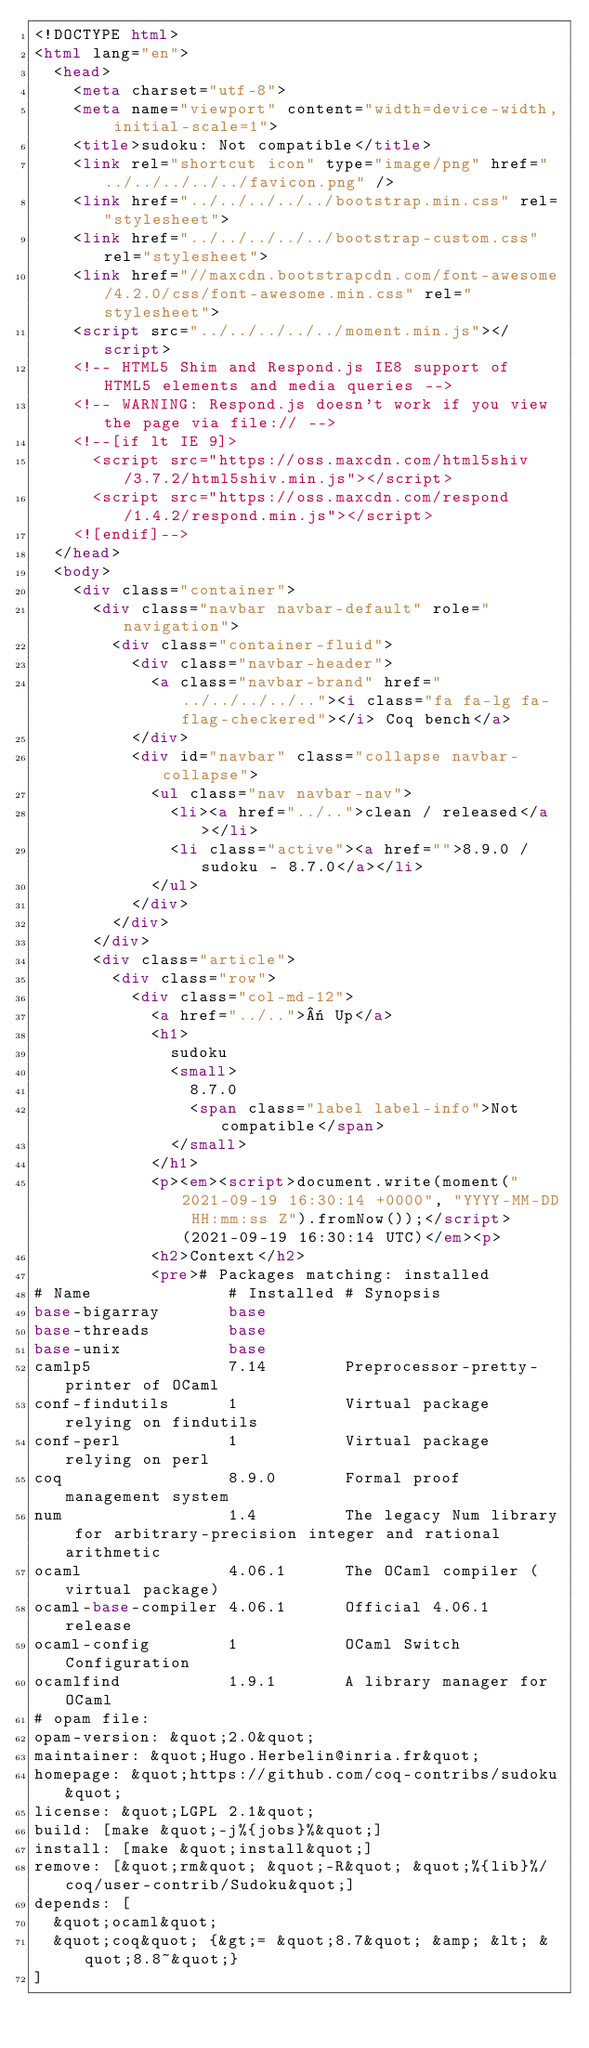Convert code to text. <code><loc_0><loc_0><loc_500><loc_500><_HTML_><!DOCTYPE html>
<html lang="en">
  <head>
    <meta charset="utf-8">
    <meta name="viewport" content="width=device-width, initial-scale=1">
    <title>sudoku: Not compatible</title>
    <link rel="shortcut icon" type="image/png" href="../../../../../favicon.png" />
    <link href="../../../../../bootstrap.min.css" rel="stylesheet">
    <link href="../../../../../bootstrap-custom.css" rel="stylesheet">
    <link href="//maxcdn.bootstrapcdn.com/font-awesome/4.2.0/css/font-awesome.min.css" rel="stylesheet">
    <script src="../../../../../moment.min.js"></script>
    <!-- HTML5 Shim and Respond.js IE8 support of HTML5 elements and media queries -->
    <!-- WARNING: Respond.js doesn't work if you view the page via file:// -->
    <!--[if lt IE 9]>
      <script src="https://oss.maxcdn.com/html5shiv/3.7.2/html5shiv.min.js"></script>
      <script src="https://oss.maxcdn.com/respond/1.4.2/respond.min.js"></script>
    <![endif]-->
  </head>
  <body>
    <div class="container">
      <div class="navbar navbar-default" role="navigation">
        <div class="container-fluid">
          <div class="navbar-header">
            <a class="navbar-brand" href="../../../../.."><i class="fa fa-lg fa-flag-checkered"></i> Coq bench</a>
          </div>
          <div id="navbar" class="collapse navbar-collapse">
            <ul class="nav navbar-nav">
              <li><a href="../..">clean / released</a></li>
              <li class="active"><a href="">8.9.0 / sudoku - 8.7.0</a></li>
            </ul>
          </div>
        </div>
      </div>
      <div class="article">
        <div class="row">
          <div class="col-md-12">
            <a href="../..">« Up</a>
            <h1>
              sudoku
              <small>
                8.7.0
                <span class="label label-info">Not compatible</span>
              </small>
            </h1>
            <p><em><script>document.write(moment("2021-09-19 16:30:14 +0000", "YYYY-MM-DD HH:mm:ss Z").fromNow());</script> (2021-09-19 16:30:14 UTC)</em><p>
            <h2>Context</h2>
            <pre># Packages matching: installed
# Name              # Installed # Synopsis
base-bigarray       base
base-threads        base
base-unix           base
camlp5              7.14        Preprocessor-pretty-printer of OCaml
conf-findutils      1           Virtual package relying on findutils
conf-perl           1           Virtual package relying on perl
coq                 8.9.0       Formal proof management system
num                 1.4         The legacy Num library for arbitrary-precision integer and rational arithmetic
ocaml               4.06.1      The OCaml compiler (virtual package)
ocaml-base-compiler 4.06.1      Official 4.06.1 release
ocaml-config        1           OCaml Switch Configuration
ocamlfind           1.9.1       A library manager for OCaml
# opam file:
opam-version: &quot;2.0&quot;
maintainer: &quot;Hugo.Herbelin@inria.fr&quot;
homepage: &quot;https://github.com/coq-contribs/sudoku&quot;
license: &quot;LGPL 2.1&quot;
build: [make &quot;-j%{jobs}%&quot;]
install: [make &quot;install&quot;]
remove: [&quot;rm&quot; &quot;-R&quot; &quot;%{lib}%/coq/user-contrib/Sudoku&quot;]
depends: [
  &quot;ocaml&quot;
  &quot;coq&quot; {&gt;= &quot;8.7&quot; &amp; &lt; &quot;8.8~&quot;}
]</code> 